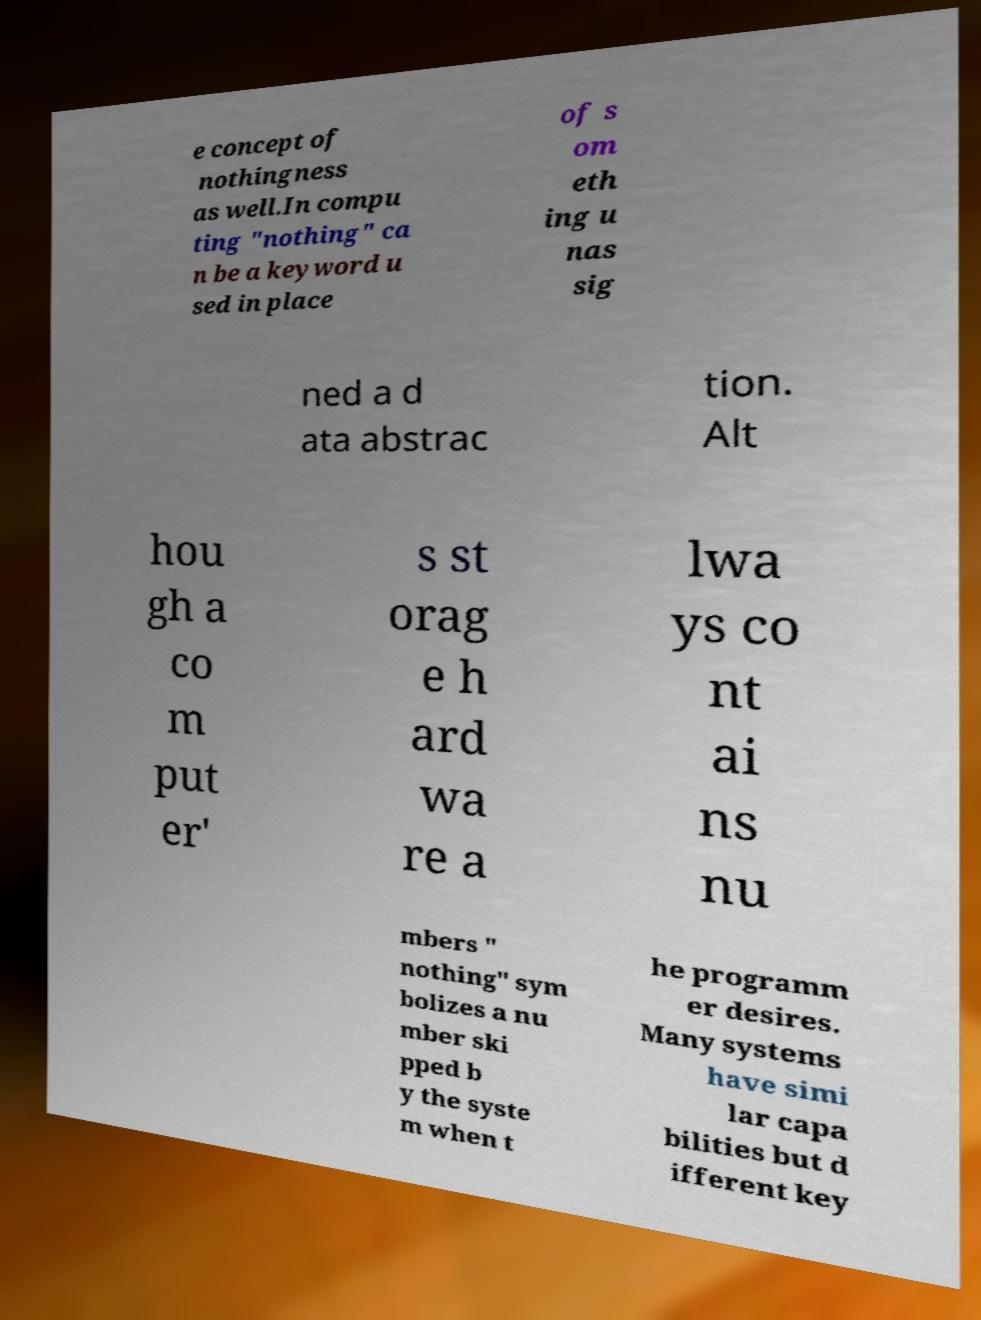Could you extract and type out the text from this image? e concept of nothingness as well.In compu ting "nothing" ca n be a keyword u sed in place of s om eth ing u nas sig ned a d ata abstrac tion. Alt hou gh a co m put er' s st orag e h ard wa re a lwa ys co nt ai ns nu mbers " nothing" sym bolizes a nu mber ski pped b y the syste m when t he programm er desires. Many systems have simi lar capa bilities but d ifferent key 